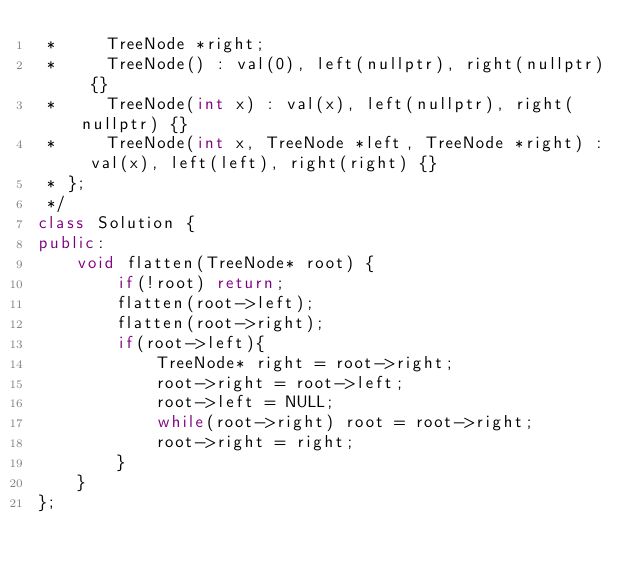<code> <loc_0><loc_0><loc_500><loc_500><_C++_> *     TreeNode *right;
 *     TreeNode() : val(0), left(nullptr), right(nullptr) {}
 *     TreeNode(int x) : val(x), left(nullptr), right(nullptr) {}
 *     TreeNode(int x, TreeNode *left, TreeNode *right) : val(x), left(left), right(right) {}
 * };
 */
class Solution {
public:
    void flatten(TreeNode* root) {
        if(!root) return;
        flatten(root->left);
        flatten(root->right);
        if(root->left){
            TreeNode* right = root->right;
            root->right = root->left;
            root->left = NULL;
            while(root->right) root = root->right;
            root->right = right;
        }        
    }
};</code> 